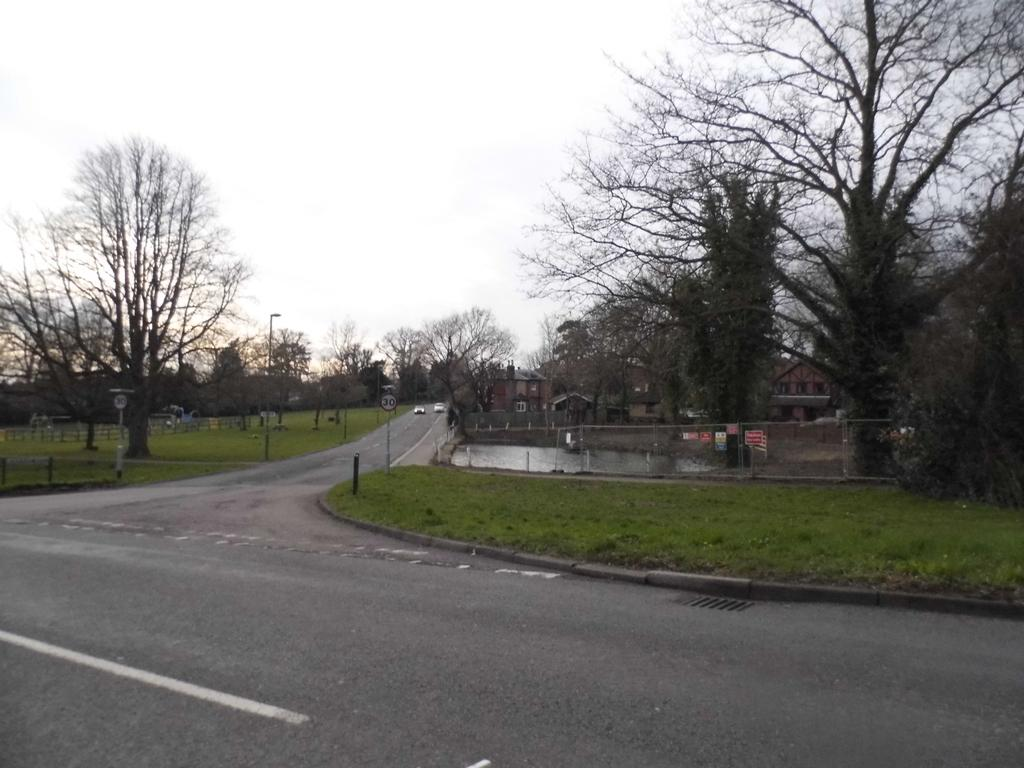What can be seen on the road in the image? There are vehicles on the road in the image. What type of natural elements are visible in the background? There are trees in the background of the image. What type of man-made structures can be seen in the background? There are buildings in the background of the image. What type of barrier is present in the background? There is a fence in the background of the image. What is visible at the bottom of the image? The ground is visible at the bottom of the image. What type of teeth can be seen in the image? There are no teeth visible in the image; it features vehicles on the road, trees, buildings, a fence, and the ground. What is the reaction of the vehicles to the fence in the image? There is no reaction of the vehicles to the fence in the image, as vehicles do not have the ability to react. 